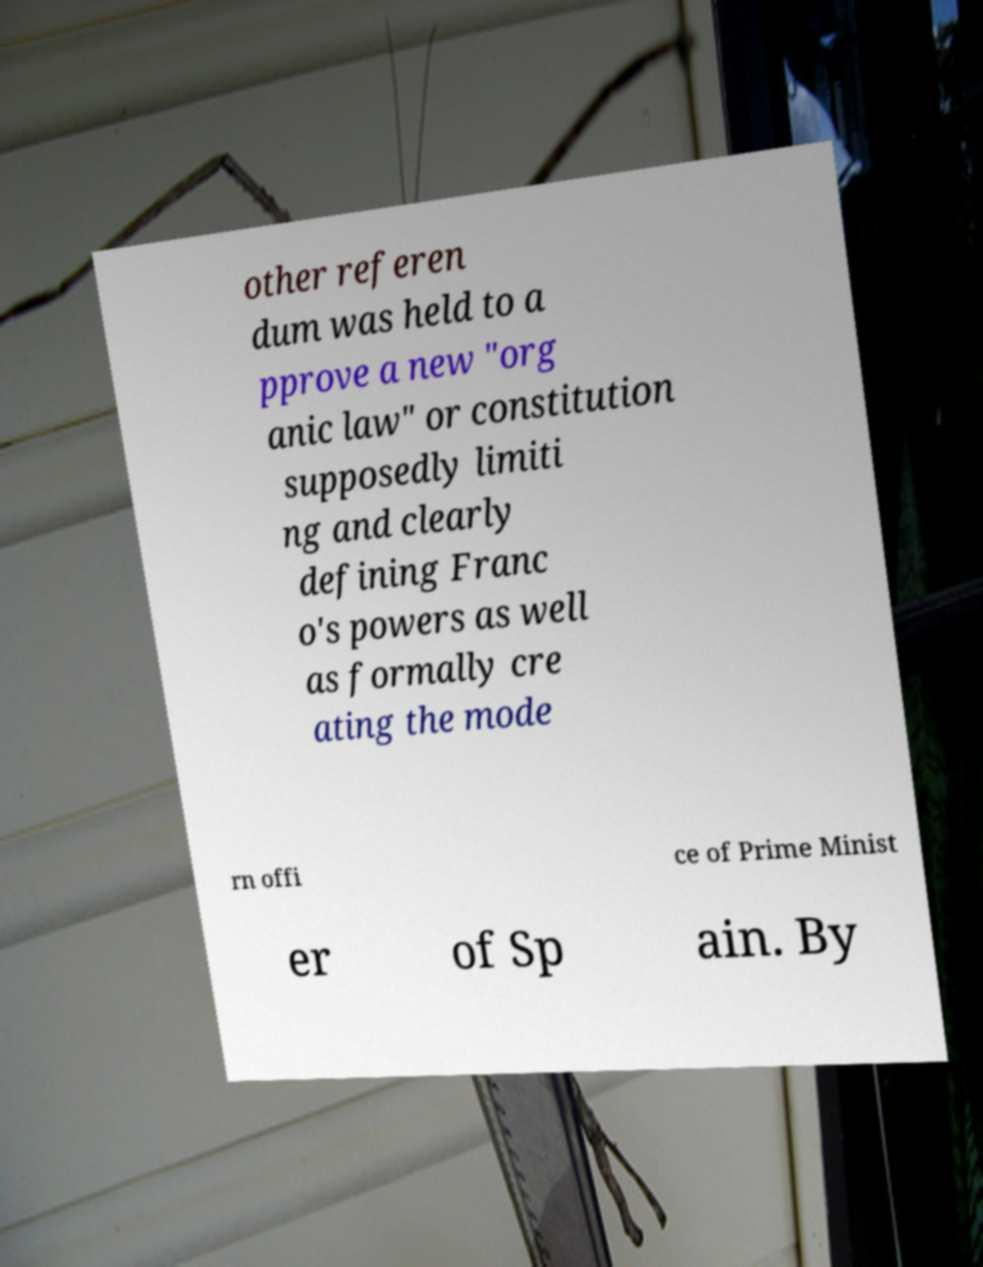Can you read and provide the text displayed in the image?This photo seems to have some interesting text. Can you extract and type it out for me? other referen dum was held to a pprove a new "org anic law" or constitution supposedly limiti ng and clearly defining Franc o's powers as well as formally cre ating the mode rn offi ce of Prime Minist er of Sp ain. By 